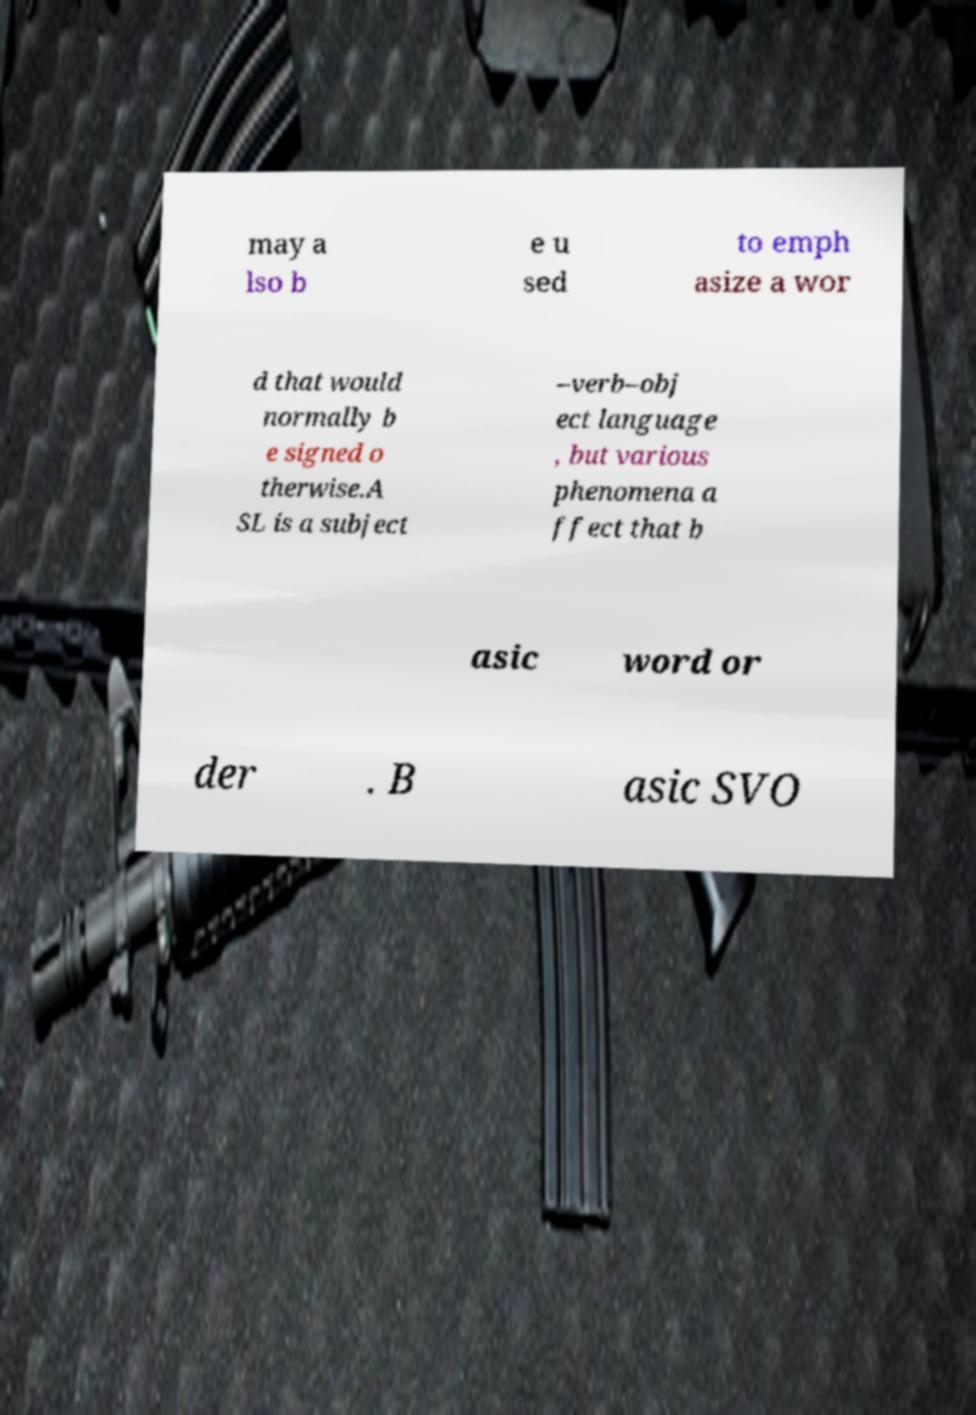Can you accurately transcribe the text from the provided image for me? may a lso b e u sed to emph asize a wor d that would normally b e signed o therwise.A SL is a subject –verb–obj ect language , but various phenomena a ffect that b asic word or der . B asic SVO 